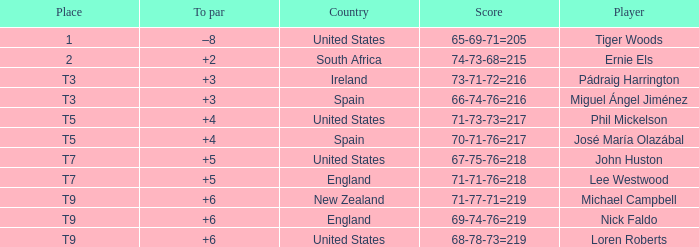What is Player, when Country is "England", and when Place is "T7"? Lee Westwood. 